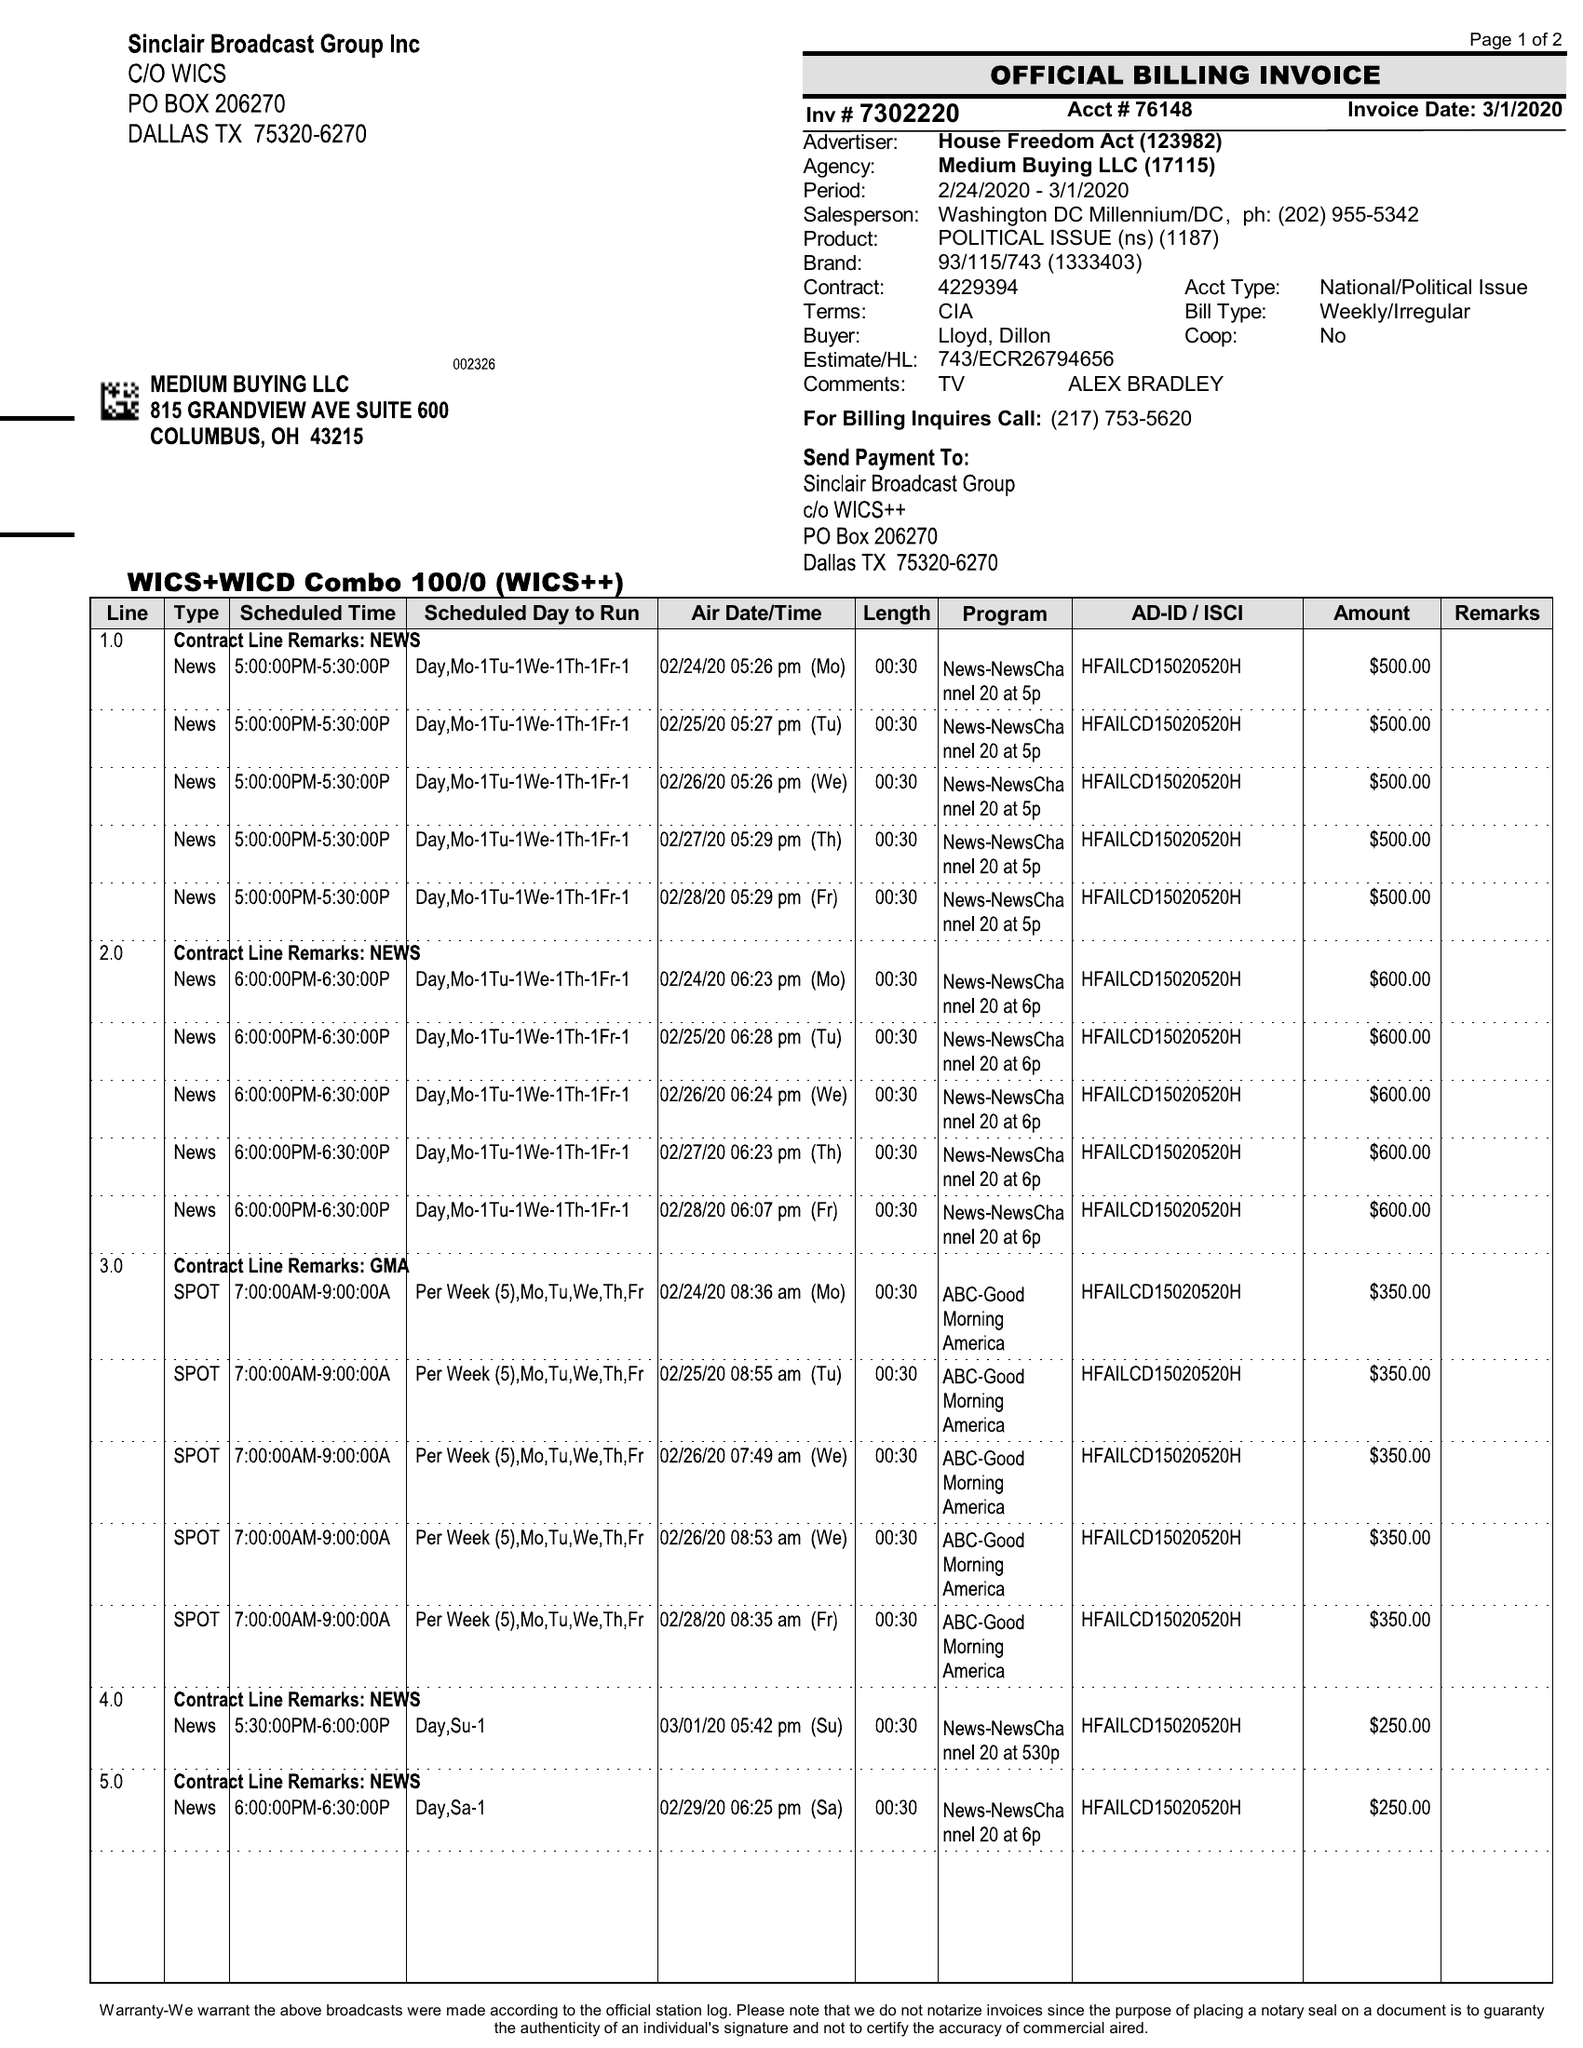What is the value for the contract_num?
Answer the question using a single word or phrase. 7302220 